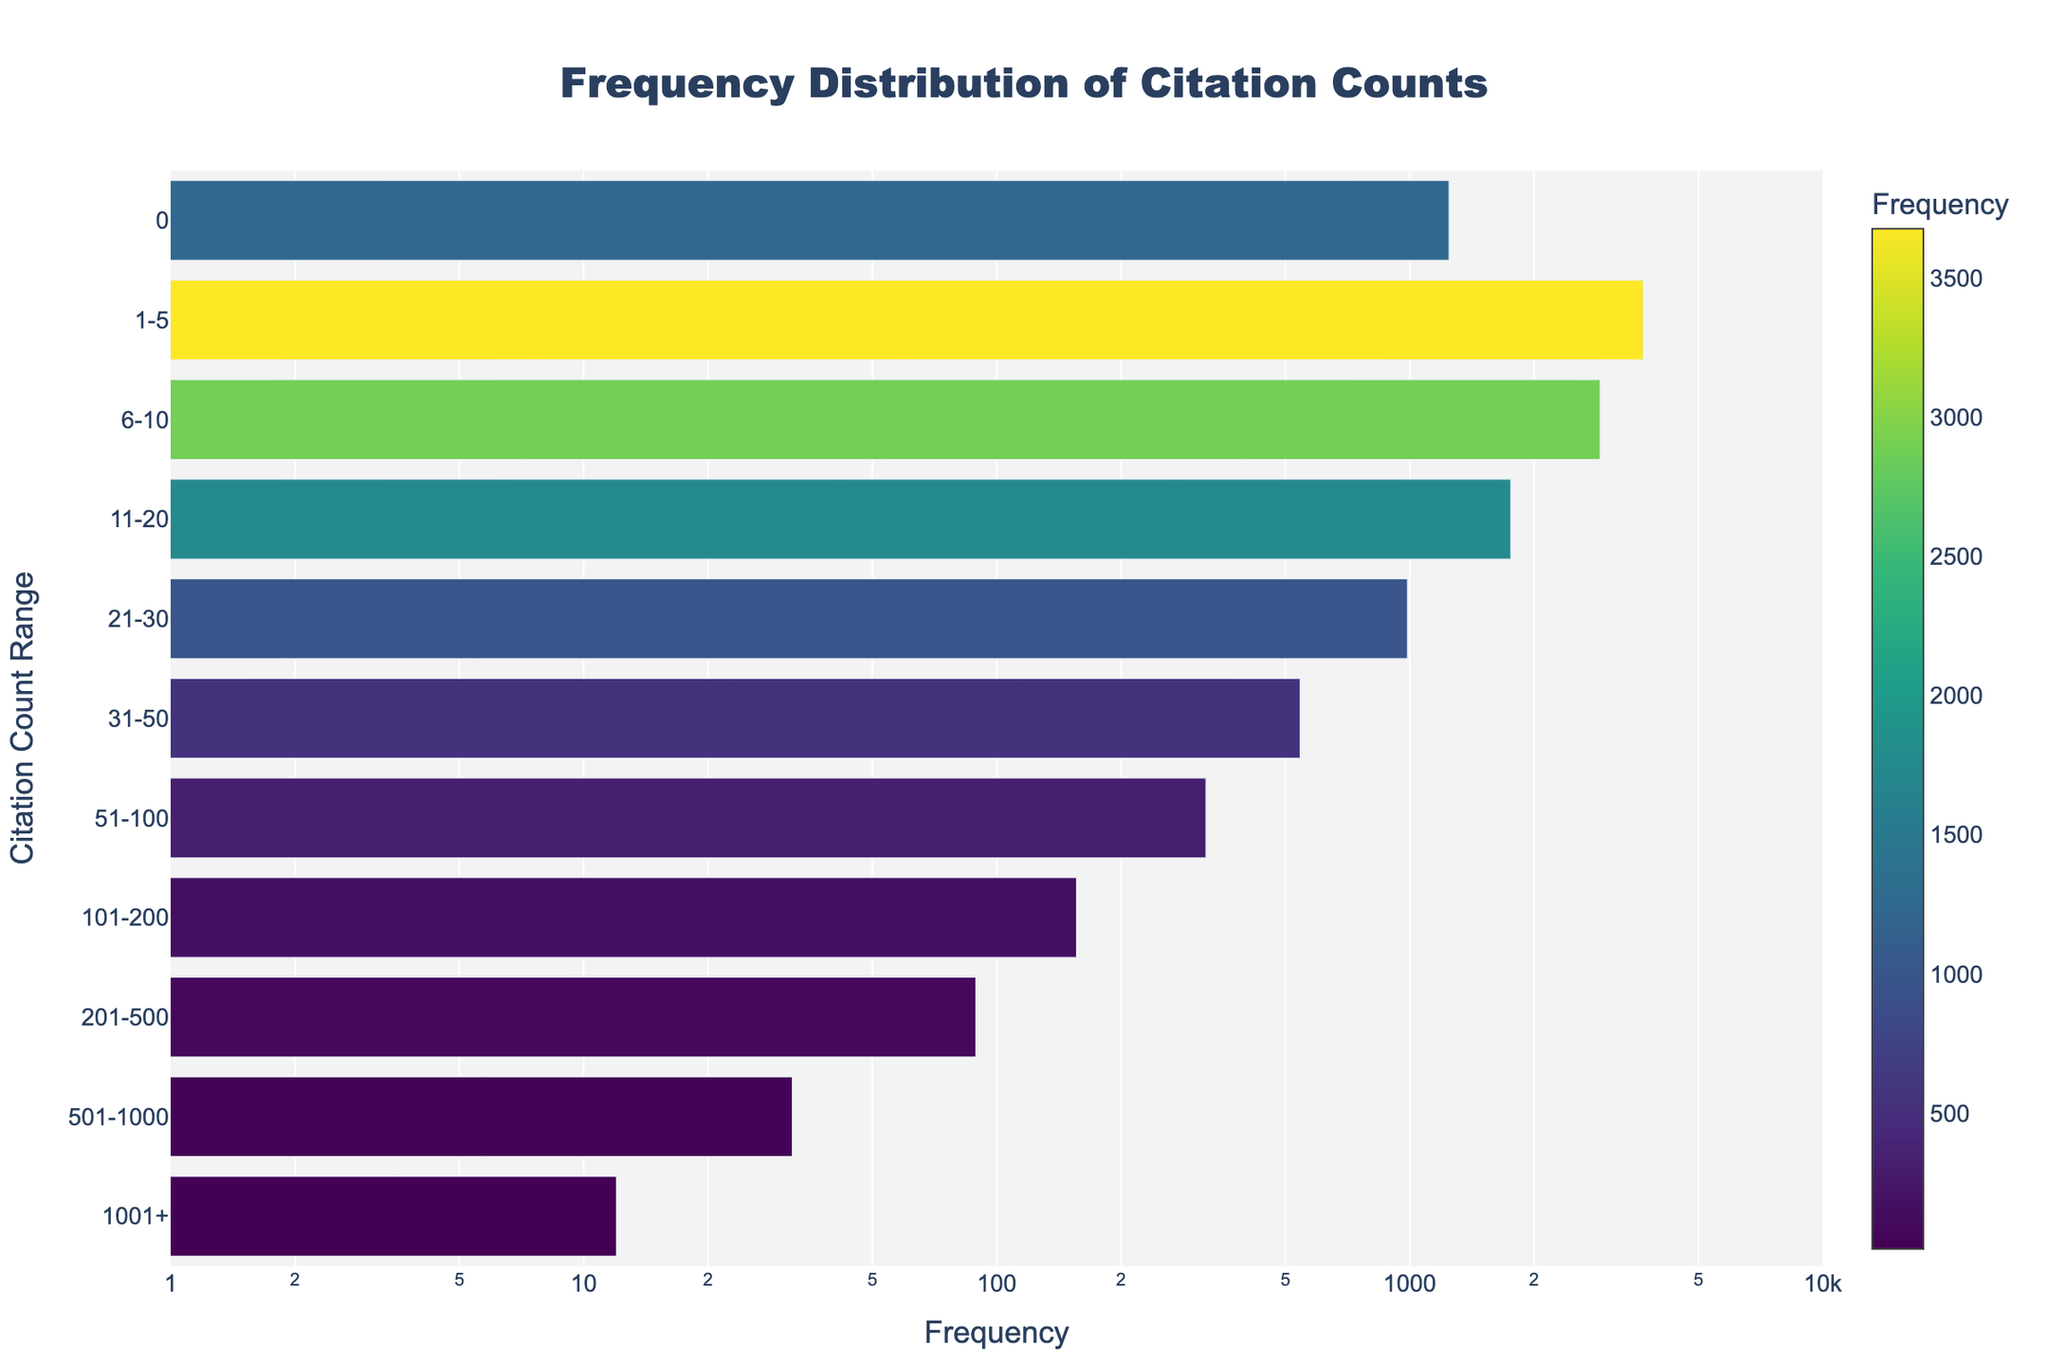Which citation count range has the highest frequency? By observing the bar corresponding to each citation count range, the bar representing the '1-5' citations range is the longest, indicating the highest frequency.
Answer: 1-5 Which citation count range has the lowest frequency? By looking at the shortest bar, which corresponds to the '1001+' citations range, it shows the lowest frequency.
Answer: 1001+ What is the approximate frequency for papers with 11-20 citations? The length of the bar for the '11-20' citation range looks to be around 1756.
Answer: 1756 How does the frequency change as the citation count range increases? The frequency tends to decrease as the citation count range increases. This is shown by progressively shorter bars as you go from '0' to '1001+'.
Answer: Decreases What is the total frequency of papers with up to 20 citations? Adding the frequencies from '0', '1-5', '6-10', and '11-20' ranges: 1245 + 3678 + 2890 + 1756 = 9569.
Answer: 9569 Is the frequency distribution skewed in any particular direction? The frequency distribution is skewed to the right, as the majority of data points have lower citation counts with a few extremely high counts.
Answer: Right How frequent are papers with more than 500 citations? Summing the frequencies of the '501-1000' and '1001+' ranges: 32 + 12 = 44.
Answer: 44 What is the range of the x-axis, and what kind of scale is applied? The x-axis represents the frequency, ranging from 1 to around 10000, and it is on a logarithmic scale.
Answer: 1 to ~10000, logarithmic Which citation count range is more frequent: '21-30' or '31-50'? Comparing the lengths of the bars, the '21-30' range has a higher frequency than the '31-50' range.
Answer: 21-30 How does the color intensity change with frequency? The color intensity in the plot increases with higher frequency. Lighter colors correspond to lower frequencies and darker colors correspond to higher frequencies.
Answer: Increases with frequency 